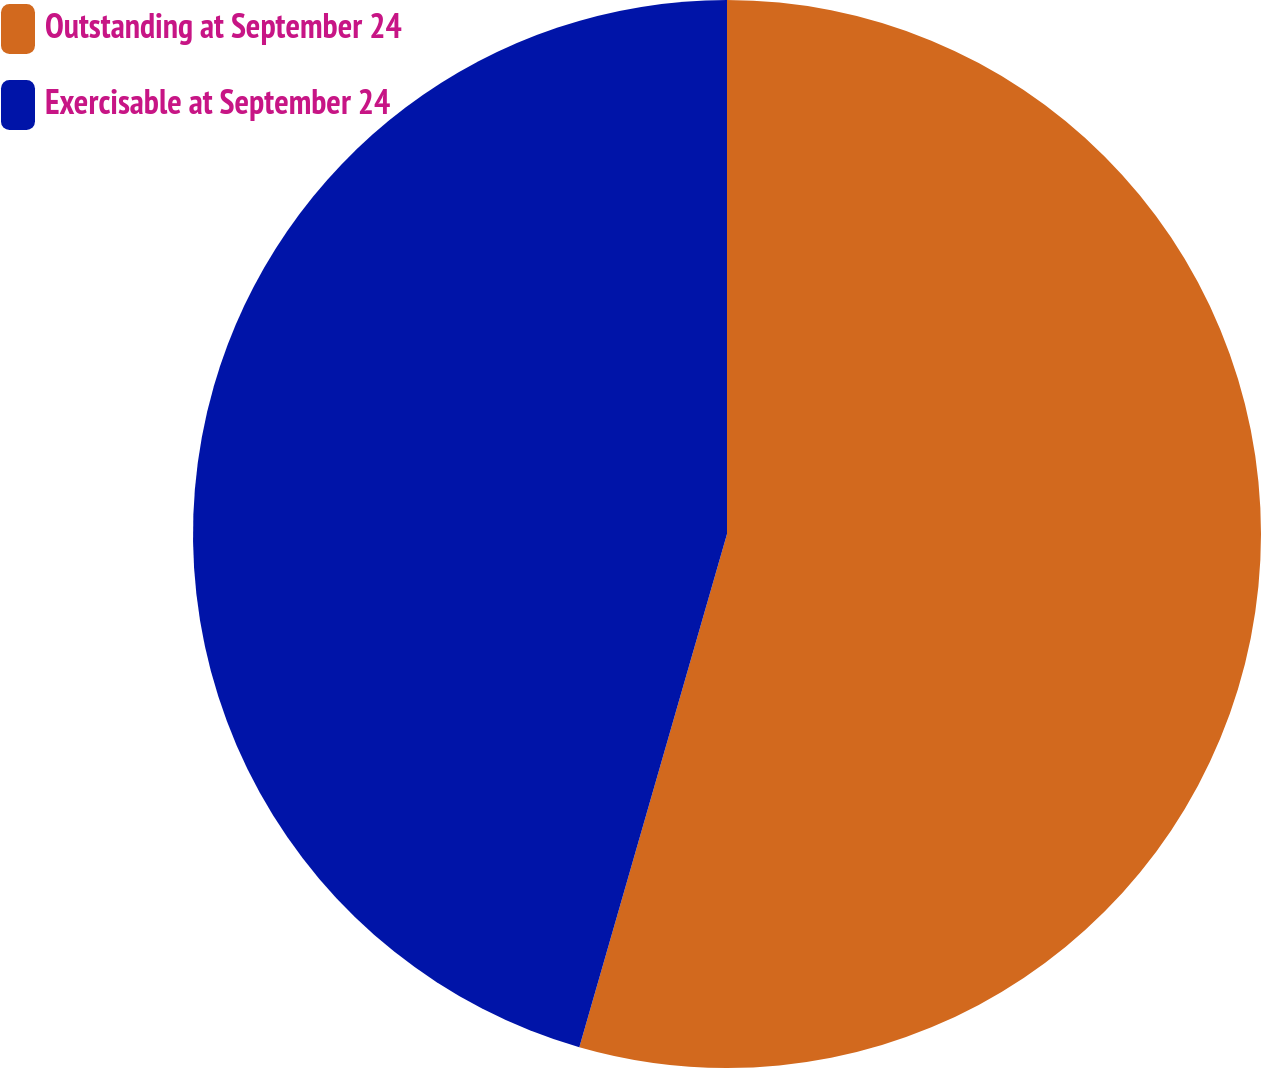Convert chart to OTSL. <chart><loc_0><loc_0><loc_500><loc_500><pie_chart><fcel>Outstanding at September 24<fcel>Exercisable at September 24<nl><fcel>54.46%<fcel>45.54%<nl></chart> 